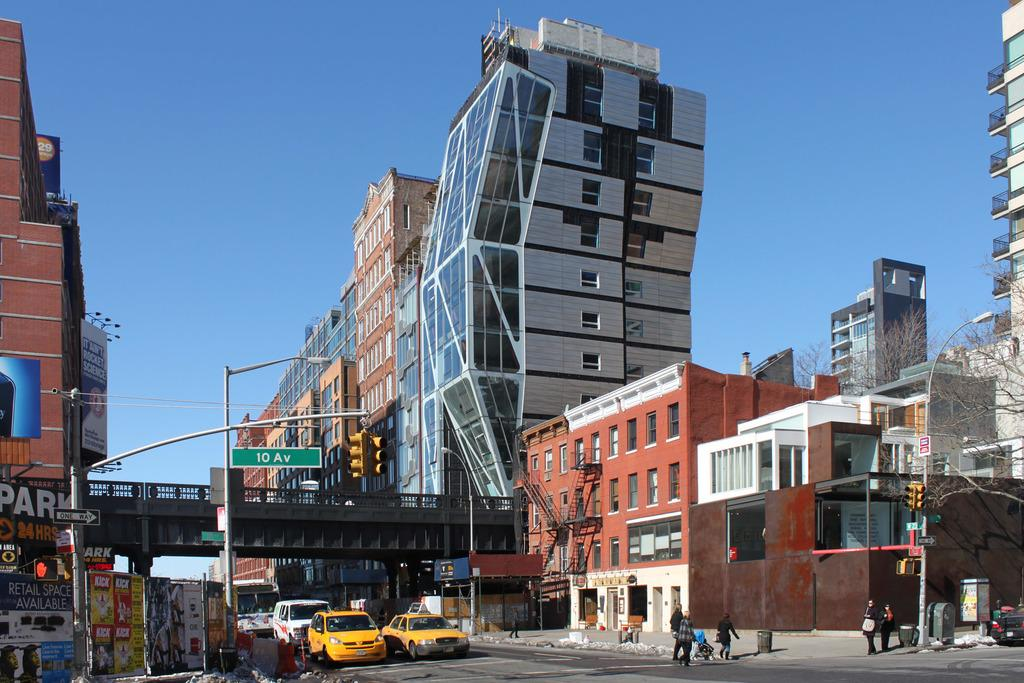<image>
Offer a succinct explanation of the picture presented. The closest street name to the camera is 10 Av 